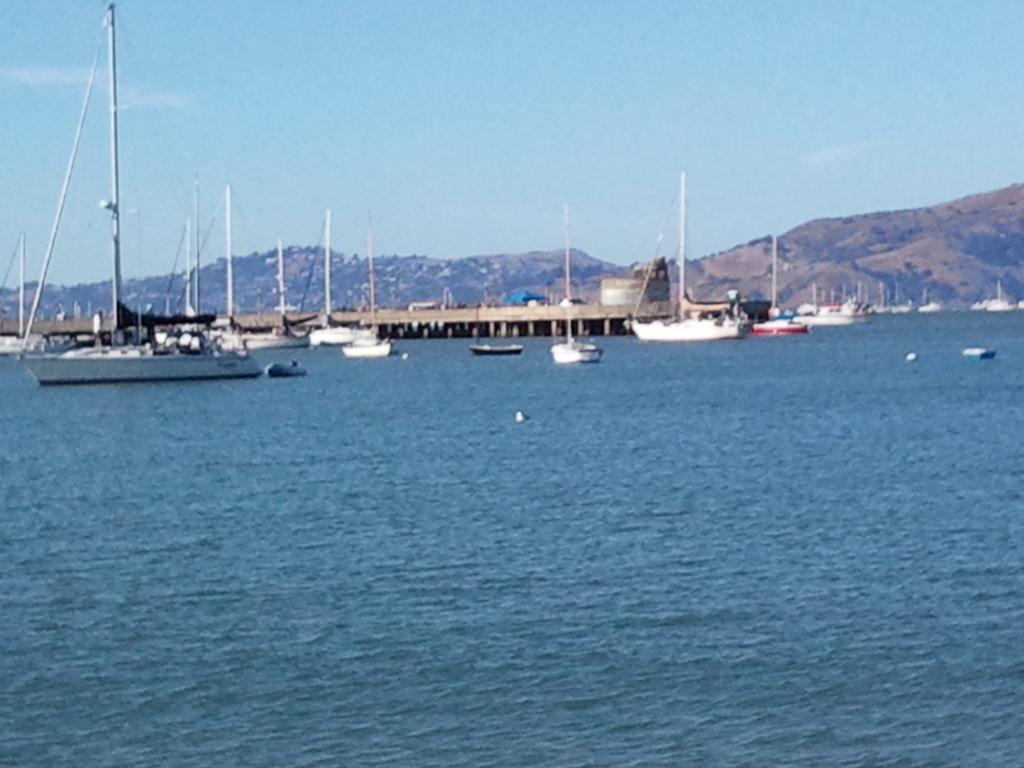Could you give a brief overview of what you see in this image? In this picture there are boats and ships in the center of the image on the water and there is a dock in the center of the image and there is greenery in the background area of the image, there is sky at the top side of the image. 